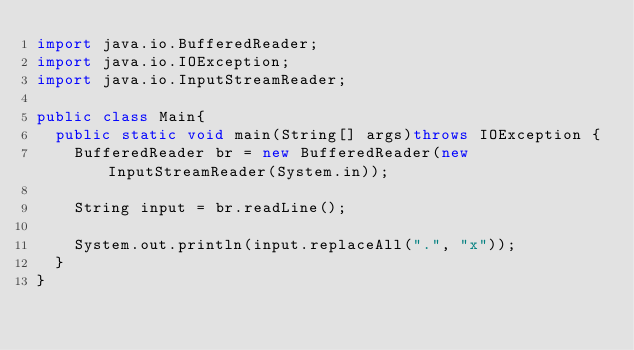<code> <loc_0><loc_0><loc_500><loc_500><_Java_>import java.io.BufferedReader;
import java.io.IOException;
import java.io.InputStreamReader;

public class Main{
  public static void main(String[] args)throws IOException {
    BufferedReader br = new BufferedReader(new InputStreamReader(System.in));
    
    String input = br.readLine();
    
    System.out.println(input.replaceAll(".", "x"));
  }
}</code> 